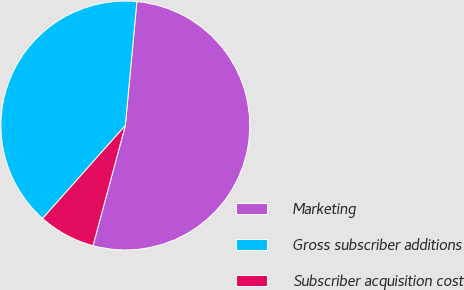<chart> <loc_0><loc_0><loc_500><loc_500><pie_chart><fcel>Marketing<fcel>Gross subscriber additions<fcel>Subscriber acquisition cost<nl><fcel>52.71%<fcel>39.9%<fcel>7.39%<nl></chart> 